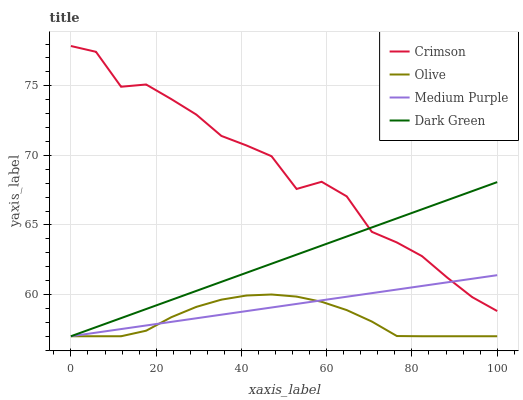Does Olive have the minimum area under the curve?
Answer yes or no. Yes. Does Crimson have the maximum area under the curve?
Answer yes or no. Yes. Does Medium Purple have the minimum area under the curve?
Answer yes or no. No. Does Medium Purple have the maximum area under the curve?
Answer yes or no. No. Is Medium Purple the smoothest?
Answer yes or no. Yes. Is Crimson the roughest?
Answer yes or no. Yes. Is Olive the smoothest?
Answer yes or no. No. Is Olive the roughest?
Answer yes or no. No. Does Olive have the lowest value?
Answer yes or no. Yes. Does Crimson have the highest value?
Answer yes or no. Yes. Does Medium Purple have the highest value?
Answer yes or no. No. Is Olive less than Crimson?
Answer yes or no. Yes. Is Crimson greater than Olive?
Answer yes or no. Yes. Does Medium Purple intersect Olive?
Answer yes or no. Yes. Is Medium Purple less than Olive?
Answer yes or no. No. Is Medium Purple greater than Olive?
Answer yes or no. No. Does Olive intersect Crimson?
Answer yes or no. No. 